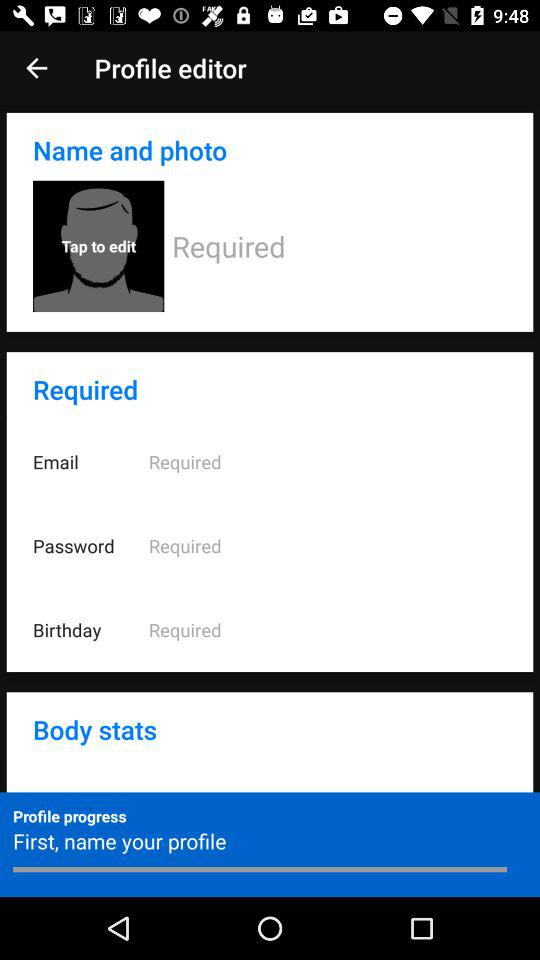How many required fields are there in the profile editor? There are four required fields in the profile editor which are 'Name and photo', 'Email', 'Password', and 'Birthday'. 